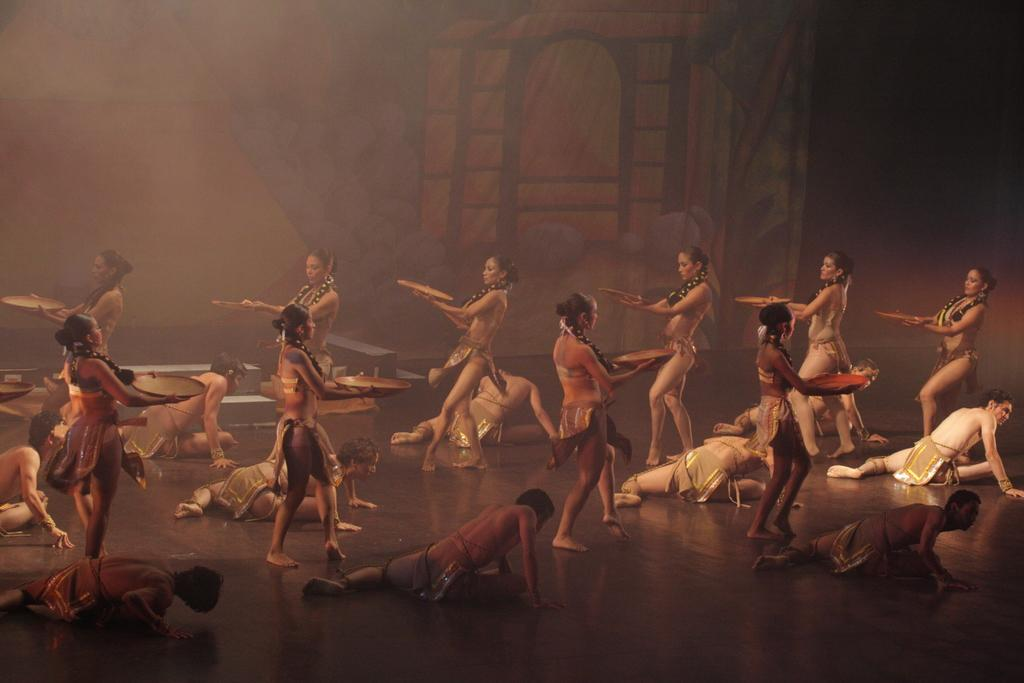How many people are present in the image? There are people in the image, but the exact number cannot be determined from the provided facts. What are some people doing in the image? Some people are holding objects in the image. What is the surface on which the people are standing? There is a ground visible in the image. What can be found on the ground in the image? There are objects on the ground in the image. What type of visual element is present in the background of the image? There is art visible in the background of the image. What type of trick does the tongue perform in the image? There is no mention of a tongue or any tricks in the image. 